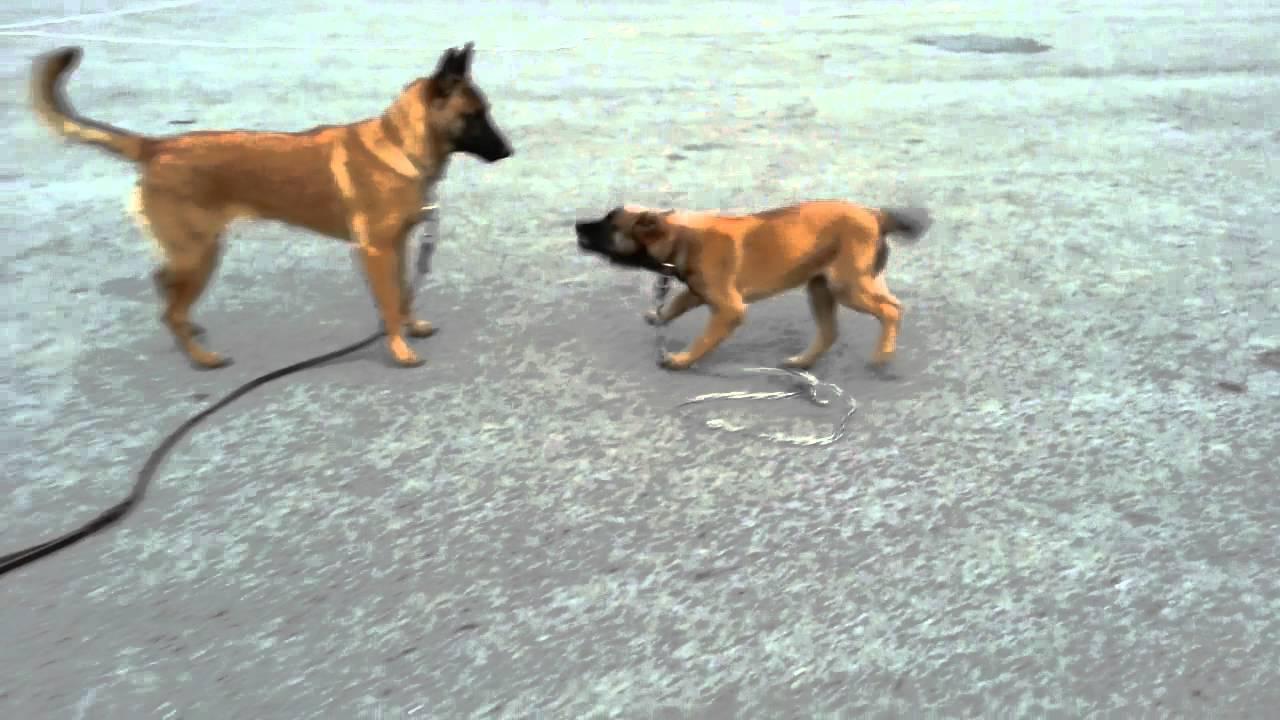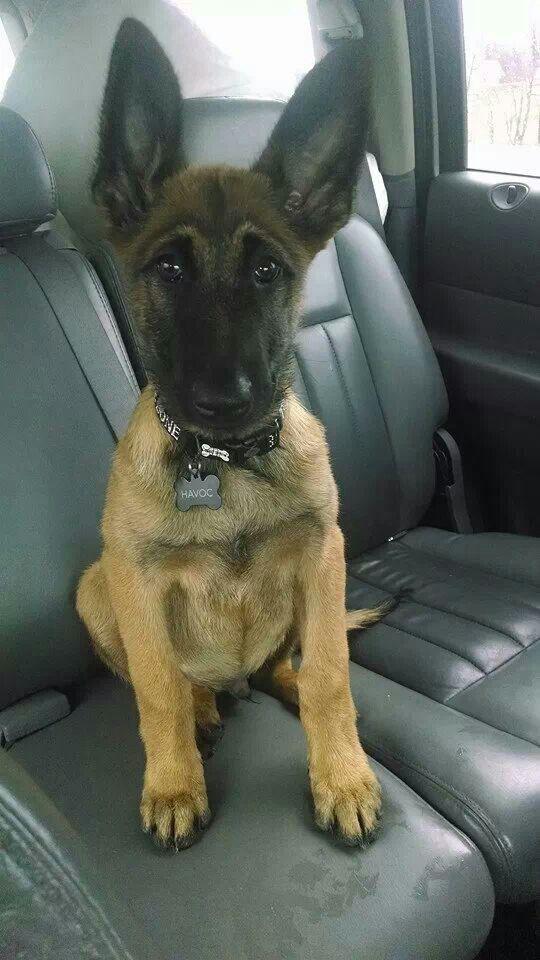The first image is the image on the left, the second image is the image on the right. Given the left and right images, does the statement "The left image contains two dogs." hold true? Answer yes or no. Yes. The first image is the image on the left, the second image is the image on the right. Assess this claim about the two images: "The righthand image contains exactly one dog, which is sitting upright with its body turned to the camera.". Correct or not? Answer yes or no. Yes. 